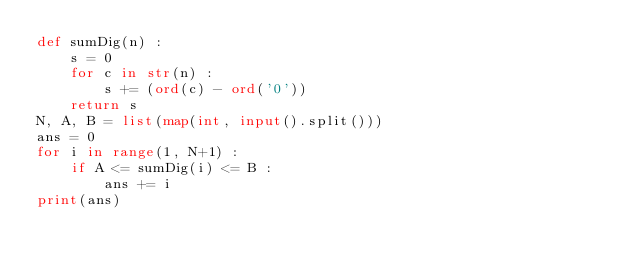<code> <loc_0><loc_0><loc_500><loc_500><_Python_>def sumDig(n) :
    s = 0
    for c in str(n) :
        s += (ord(c) - ord('0'))
    return s
N, A, B = list(map(int, input().split()))
ans = 0
for i in range(1, N+1) :
    if A <= sumDig(i) <= B :
        ans += i
print(ans)
</code> 